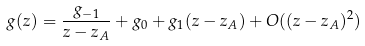<formula> <loc_0><loc_0><loc_500><loc_500>g ( z ) = \frac { g _ { - 1 } } { z - z _ { A } } + g _ { 0 } + g _ { 1 } ( z - z _ { A } ) + O ( ( z - z _ { A } ) ^ { 2 } )</formula> 